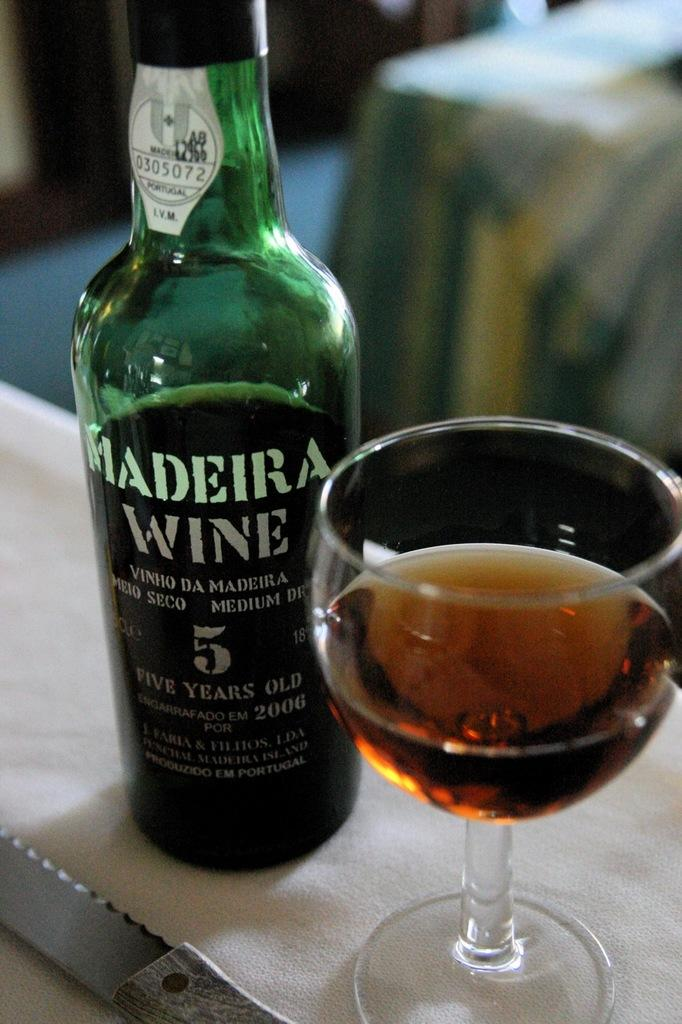Provide a one-sentence caption for the provided image. A bottle of Madeira Wine sits next to full wine glass. 